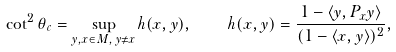<formula> <loc_0><loc_0><loc_500><loc_500>\cot ^ { 2 } \theta _ { c } = \sup _ { y , x \in M , \, y \ne x } h ( x , y ) , \quad h ( x , y ) = \frac { 1 - \langle y , P _ { x } y \rangle } { ( 1 - \langle x , y \rangle ) ^ { 2 } } ,</formula> 